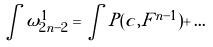Convert formula to latex. <formula><loc_0><loc_0><loc_500><loc_500>\int \omega _ { 2 n - 2 } ^ { 1 } = \int P ( c , F ^ { n - 1 } ) + \dots</formula> 